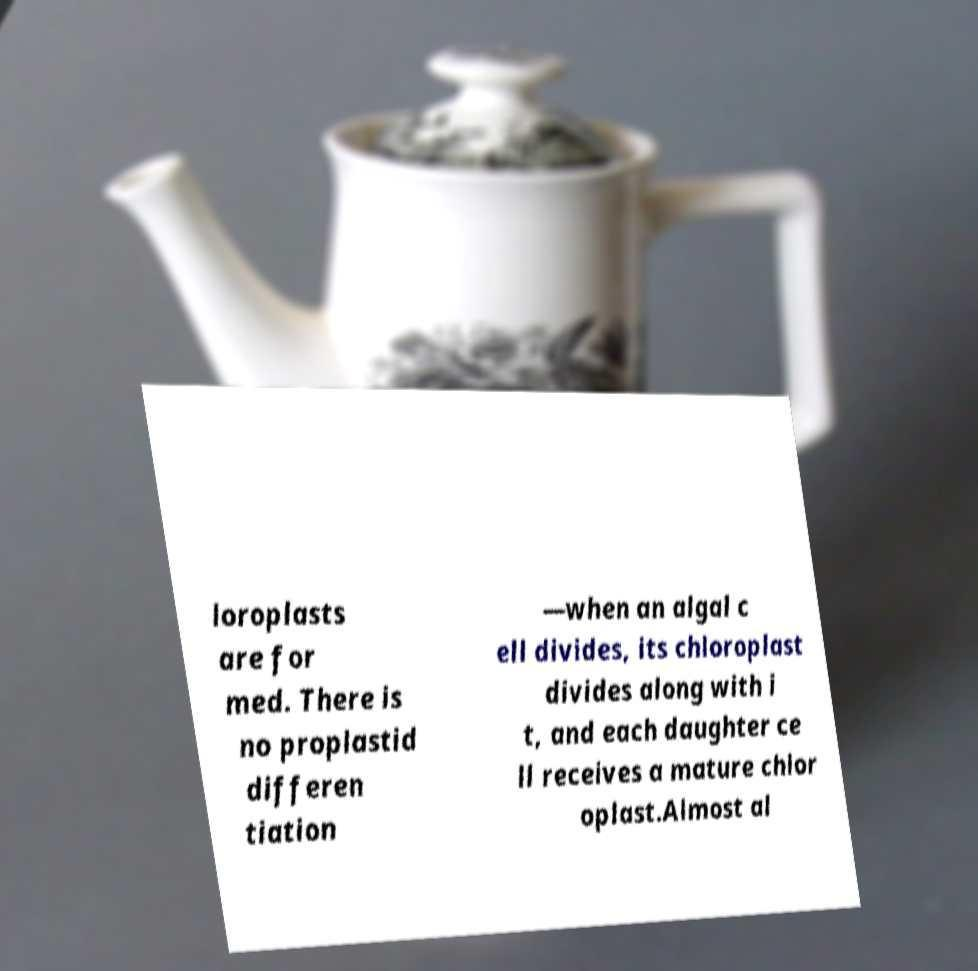Please read and relay the text visible in this image. What does it say? loroplasts are for med. There is no proplastid differen tiation —when an algal c ell divides, its chloroplast divides along with i t, and each daughter ce ll receives a mature chlor oplast.Almost al 